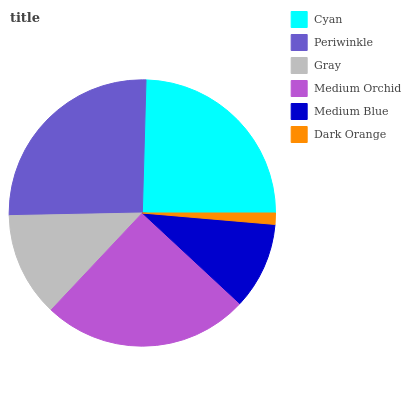Is Dark Orange the minimum?
Answer yes or no. Yes. Is Periwinkle the maximum?
Answer yes or no. Yes. Is Gray the minimum?
Answer yes or no. No. Is Gray the maximum?
Answer yes or no. No. Is Periwinkle greater than Gray?
Answer yes or no. Yes. Is Gray less than Periwinkle?
Answer yes or no. Yes. Is Gray greater than Periwinkle?
Answer yes or no. No. Is Periwinkle less than Gray?
Answer yes or no. No. Is Cyan the high median?
Answer yes or no. Yes. Is Gray the low median?
Answer yes or no. Yes. Is Medium Blue the high median?
Answer yes or no. No. Is Cyan the low median?
Answer yes or no. No. 